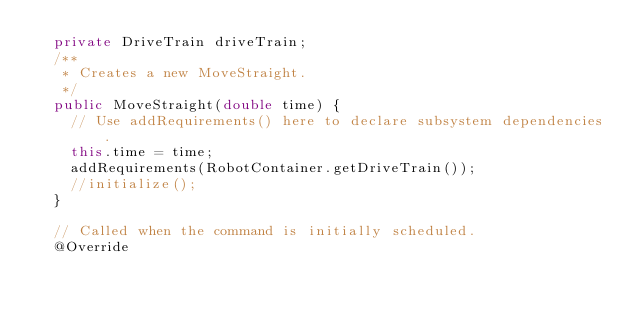Convert code to text. <code><loc_0><loc_0><loc_500><loc_500><_Java_>  private DriveTrain driveTrain;
  /**
   * Creates a new MoveStraight.
   */
  public MoveStraight(double time) {
    // Use addRequirements() here to declare subsystem dependencies.
    this.time = time;
    addRequirements(RobotContainer.getDriveTrain());
    //initialize();
  }

  // Called when the command is initially scheduled.
  @Override</code> 